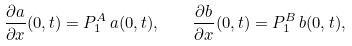<formula> <loc_0><loc_0><loc_500><loc_500>\frac { \partial a } { \partial x } ( 0 , t ) = P ^ { A } _ { 1 } \, a ( 0 , t ) , \quad \frac { \partial b } { \partial x } ( 0 , t ) = P ^ { B } _ { 1 } \, b ( 0 , t ) ,</formula> 